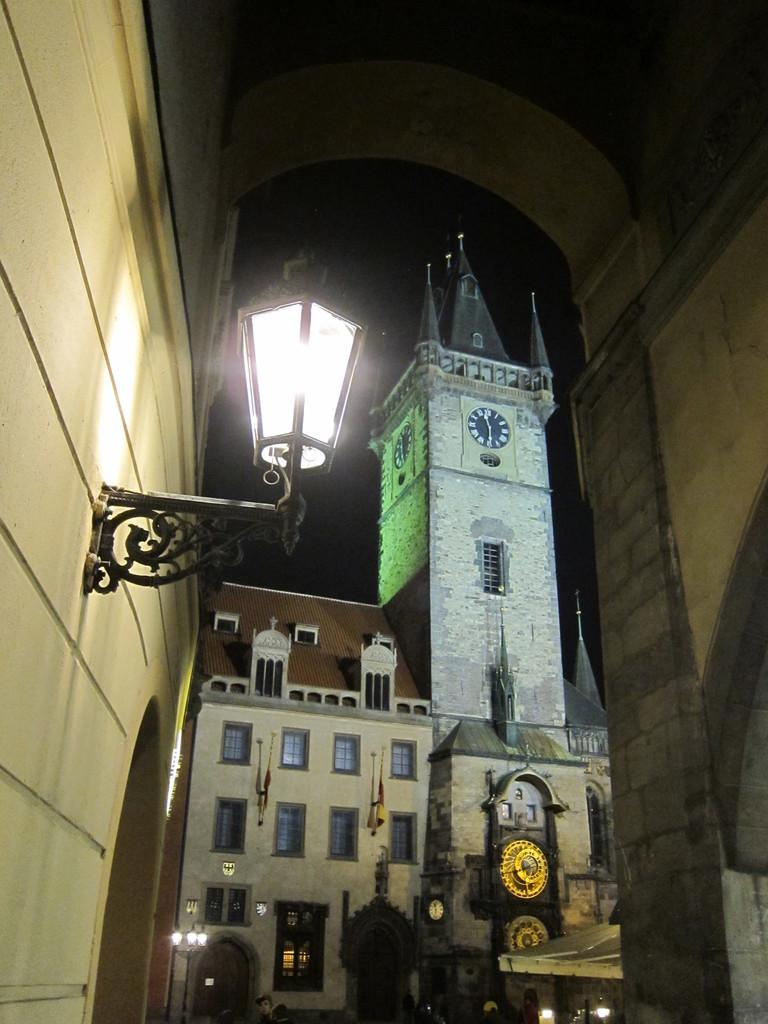What type of structures can be seen in the image? There are buildings in the image. Can you describe any specific features of the buildings? Yes, there is a lamp hanging on the wall of a building. What type of cloth is being used to fly a kite in the image? There is no kite or cloth present in the image; it only features buildings and a lamp hanging on the wall. 